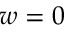Convert formula to latex. <formula><loc_0><loc_0><loc_500><loc_500>w = 0</formula> 